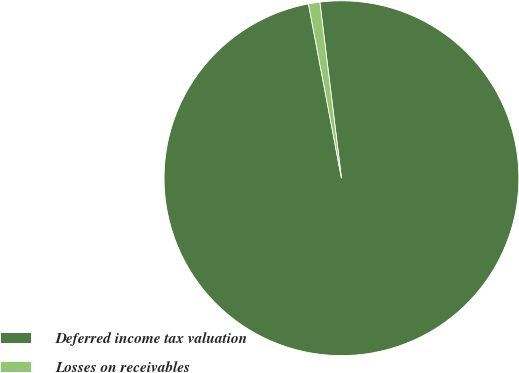Convert chart to OTSL. <chart><loc_0><loc_0><loc_500><loc_500><pie_chart><fcel>Deferred income tax valuation<fcel>Losses on receivables<nl><fcel>98.97%<fcel>1.03%<nl></chart> 